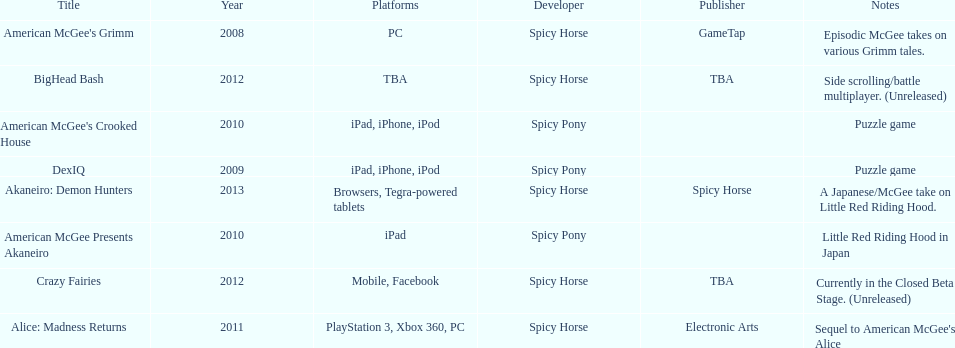Could you parse the entire table as a dict? {'header': ['Title', 'Year', 'Platforms', 'Developer', 'Publisher', 'Notes'], 'rows': [["American McGee's Grimm", '2008', 'PC', 'Spicy Horse', 'GameTap', 'Episodic McGee takes on various Grimm tales.'], ['BigHead Bash', '2012', 'TBA', 'Spicy Horse', 'TBA', 'Side scrolling/battle multiplayer. (Unreleased)'], ["American McGee's Crooked House", '2010', 'iPad, iPhone, iPod', 'Spicy Pony', '', 'Puzzle game'], ['DexIQ', '2009', 'iPad, iPhone, iPod', 'Spicy Pony', '', 'Puzzle game'], ['Akaneiro: Demon Hunters', '2013', 'Browsers, Tegra-powered tablets', 'Spicy Horse', 'Spicy Horse', 'A Japanese/McGee take on Little Red Riding Hood.'], ['American McGee Presents Akaneiro', '2010', 'iPad', 'Spicy Pony', '', 'Little Red Riding Hood in Japan'], ['Crazy Fairies', '2012', 'Mobile, Facebook', 'Spicy Horse', 'TBA', 'Currently in the Closed Beta Stage. (Unreleased)'], ['Alice: Madness Returns', '2011', 'PlayStation 3, Xbox 360, PC', 'Spicy Horse', 'Electronic Arts', "Sequel to American McGee's Alice"]]} Spicy pony released a total of three games; their game, "american mcgee's crooked house" was released on which platforms? Ipad, iphone, ipod. 